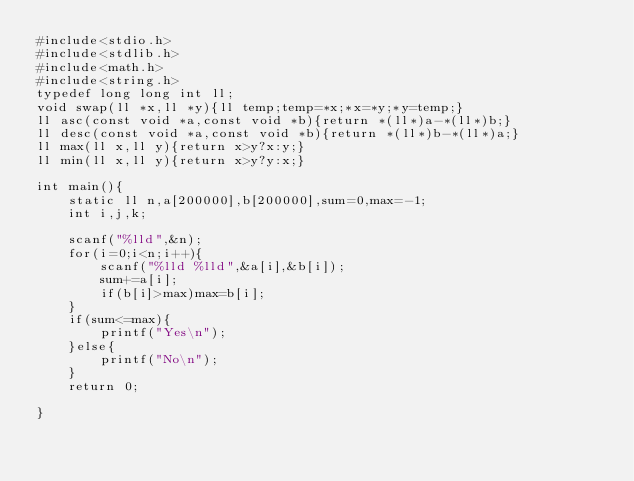Convert code to text. <code><loc_0><loc_0><loc_500><loc_500><_C_>#include<stdio.h>
#include<stdlib.h>
#include<math.h>
#include<string.h>
typedef long long int ll;
void swap(ll *x,ll *y){ll temp;temp=*x;*x=*y;*y=temp;}
ll asc(const void *a,const void *b){return *(ll*)a-*(ll*)b;}
ll desc(const void *a,const void *b){return *(ll*)b-*(ll*)a;}
ll max(ll x,ll y){return x>y?x:y;}
ll min(ll x,ll y){return x>y?y:x;}

int main(){
    static ll n,a[200000],b[200000],sum=0,max=-1;
    int i,j,k;

    scanf("%lld",&n);
    for(i=0;i<n;i++){
        scanf("%lld %lld",&a[i],&b[i]);
        sum+=a[i];
        if(b[i]>max)max=b[i];
    }
    if(sum<=max){
        printf("Yes\n");
    }else{
        printf("No\n");
    }
    return 0;

}</code> 